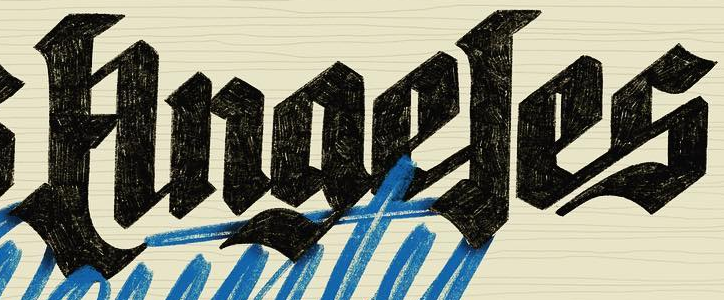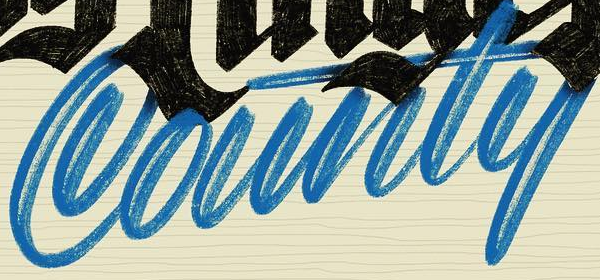What words are shown in these images in order, separated by a semicolon? Anaeles; County 